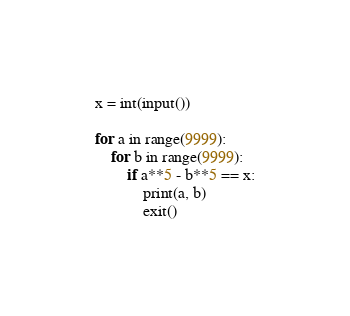Convert code to text. <code><loc_0><loc_0><loc_500><loc_500><_Python_>x = int(input())

for a in range(9999):
    for b in range(9999):
        if a**5 - b**5 == x:
            print(a, b)
            exit()
</code> 